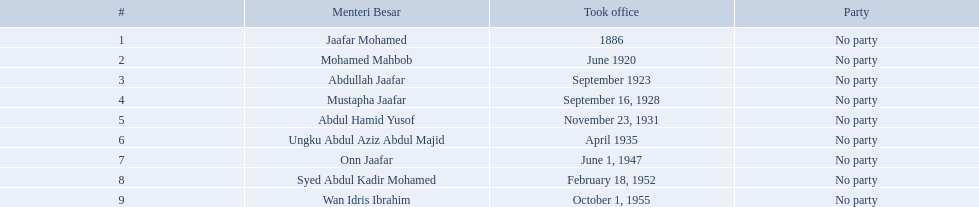Who were the menteri besar of johor? Jaafar Mohamed, Mohamed Mahbob, Abdullah Jaafar, Mustapha Jaafar, Abdul Hamid Yusof, Ungku Abdul Aziz Abdul Majid, Onn Jaafar, Syed Abdul Kadir Mohamed, Wan Idris Ibrahim. Who served the longest? Ungku Abdul Aziz Abdul Majid. Who are all of the menteri besars? Jaafar Mohamed, Mohamed Mahbob, Abdullah Jaafar, Mustapha Jaafar, Abdul Hamid Yusof, Ungku Abdul Aziz Abdul Majid, Onn Jaafar, Syed Abdul Kadir Mohamed, Wan Idris Ibrahim. When did each take office? 1886, June 1920, September 1923, September 16, 1928, November 23, 1931, April 1935, June 1, 1947, February 18, 1952, October 1, 1955. When did they leave? July 1890, 1922, 1928, November 23, 1931, December 28, 1934, June 1, 1947, May 18, 1950, June 5, 1955, August 31, 1957. And which spent the most time in office? Ungku Abdul Aziz Abdul Majid. Who were all of the menteri besars? Jaafar Mohamed, Mohamed Mahbob, Abdullah Jaafar, Mustapha Jaafar, Abdul Hamid Yusof, Ungku Abdul Aziz Abdul Majid, Onn Jaafar, Syed Abdul Kadir Mohamed, Wan Idris Ibrahim. When did they take office? 1886, June 1920, September 1923, September 16, 1928, November 23, 1931, April 1935, June 1, 1947, February 18, 1952, October 1, 1955. And when did they leave? July 1890, 1922, 1928, November 23, 1931, December 28, 1934, June 1, 1947, May 18, 1950, June 5, 1955, August 31, 1957. Now, who was in office for less than four years? Mohamed Mahbob. 